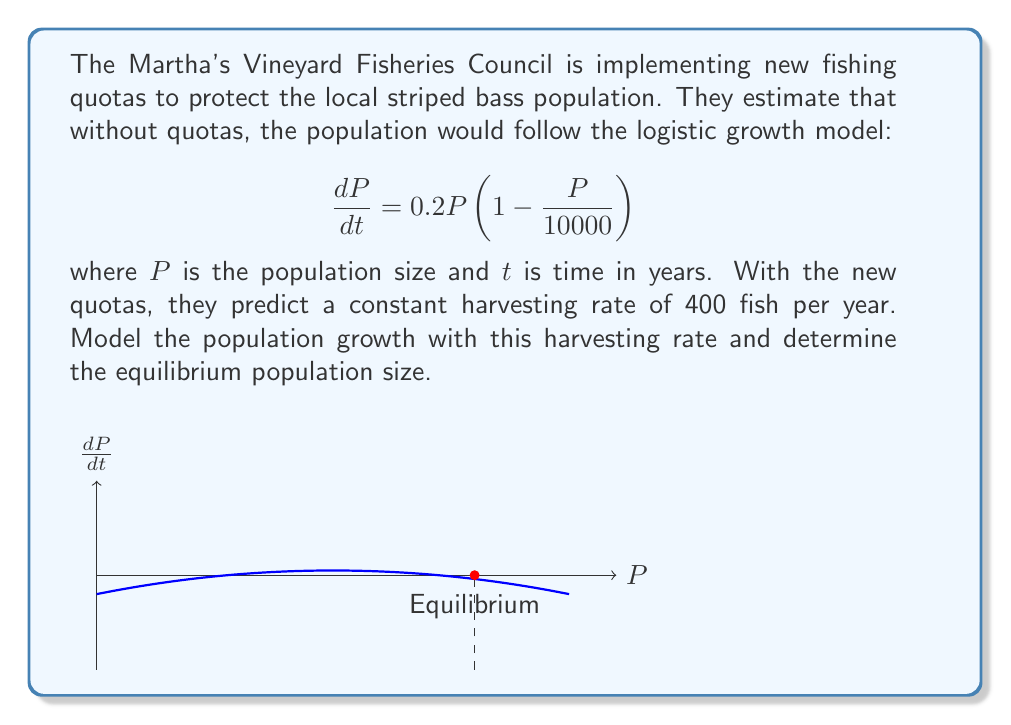Provide a solution to this math problem. Let's approach this step-by-step:

1) The new model with harvesting is:

   $$\frac{dP}{dt} = 0.2P(1 - \frac{P}{10000}) - 400$$

2) At equilibrium, $\frac{dP}{dt} = 0$. So we need to solve:

   $$0 = 0.2P(1 - \frac{P}{10000}) - 400$$

3) Multiply both sides by 5:

   $$0 = P(1 - \frac{P}{10000}) - 2000$$

4) Expand the brackets:

   $$0 = P - \frac{P^2}{10000} - 2000$$

5) Multiply everything by 10000:

   $$0 = 10000P - P^2 - 20000000$$

6) Rearrange to standard quadratic form:

   $$P^2 - 10000P + 20000000 = 0$$

7) Use the quadratic formula $\frac{-b \pm \sqrt{b^2 - 4ac}}{2a}$:

   $$P = \frac{10000 \pm \sqrt{100000000 - 80000000}}{2}$$

8) Simplify:

   $$P = \frac{10000 \pm \sqrt{20000000}}{2} = \frac{10000 \pm 4472}{2}$$

9) This gives us two solutions:

   $$P = 7236 \text{ or } P = 2764$$

10) The larger solution (7236) is the stable equilibrium, as seen in the graph.
Answer: 7236 fish 